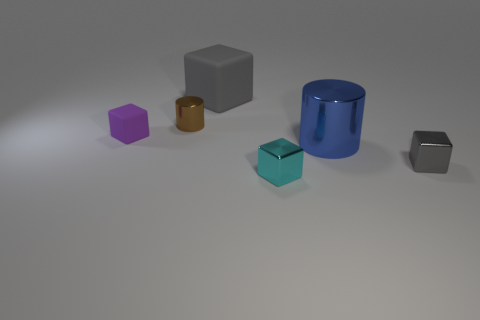There is a shiny thing that is behind the tiny gray metal cube and to the right of the large rubber cube; what is its size?
Provide a succinct answer. Large. Is the color of the large block the same as the thing on the right side of the big blue shiny object?
Your response must be concise. Yes. There is a metallic block that is to the right of the big cylinder; does it have the same color as the big thing that is left of the big metallic object?
Offer a terse response. Yes. The other object that is the same shape as the brown shiny object is what size?
Offer a very short reply. Large. Do the blue thing and the brown object have the same shape?
Keep it short and to the point. Yes. There is a gray block that is in front of the gray cube behind the large cylinder; what is it made of?
Your response must be concise. Metal. There is a small object that is the same color as the big rubber block; what material is it?
Offer a terse response. Metal. Does the purple cube have the same size as the gray metal object?
Your answer should be compact. Yes. Are there any tiny shiny blocks to the left of the big thing that is in front of the purple matte cube?
Keep it short and to the point. Yes. There is another shiny block that is the same color as the large block; what size is it?
Offer a terse response. Small. 